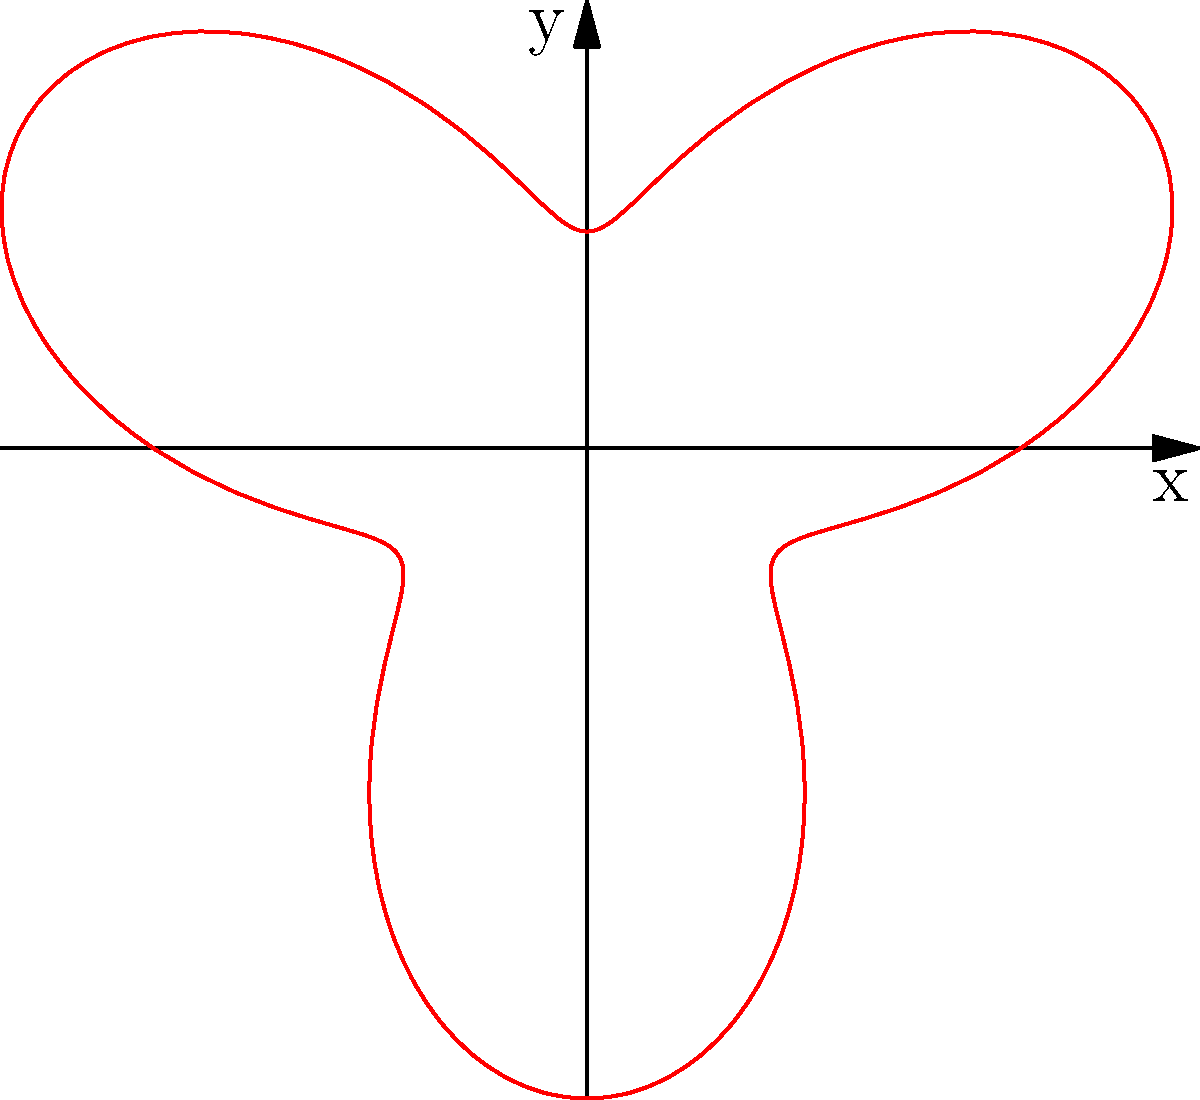In a gymnastics competition, Gabriela Barbosa performs an aerial somersault. The path of her center of mass during the somersault can be described by the polar equation $r = 2 + \sin(3\theta)$, where $r$ is in meters. What is the maximum distance (in meters) from the origin that Gabriela reaches during her somersault? To find the maximum distance from the origin, we need to determine the maximum value of $r$ in the given polar equation.

1. The equation is given as $r = 2 + \sin(3\theta)$

2. We know that the sine function has a range of [-1, 1]

3. The maximum value of $\sin(3\theta)$ is 1

4. Therefore, the maximum value of $r$ occurs when $\sin(3\theta) = 1$

5. Substituting this into the equation:
   $r_{max} = 2 + 1 = 3$

6. Thus, the maximum distance from the origin is 3 meters

This maximum distance occurs when $\sin(3\theta) = 1$, which happens multiple times during Gabriela's somersault, corresponding to the outermost points of the "petals" in the polar graph.
Answer: 3 meters 